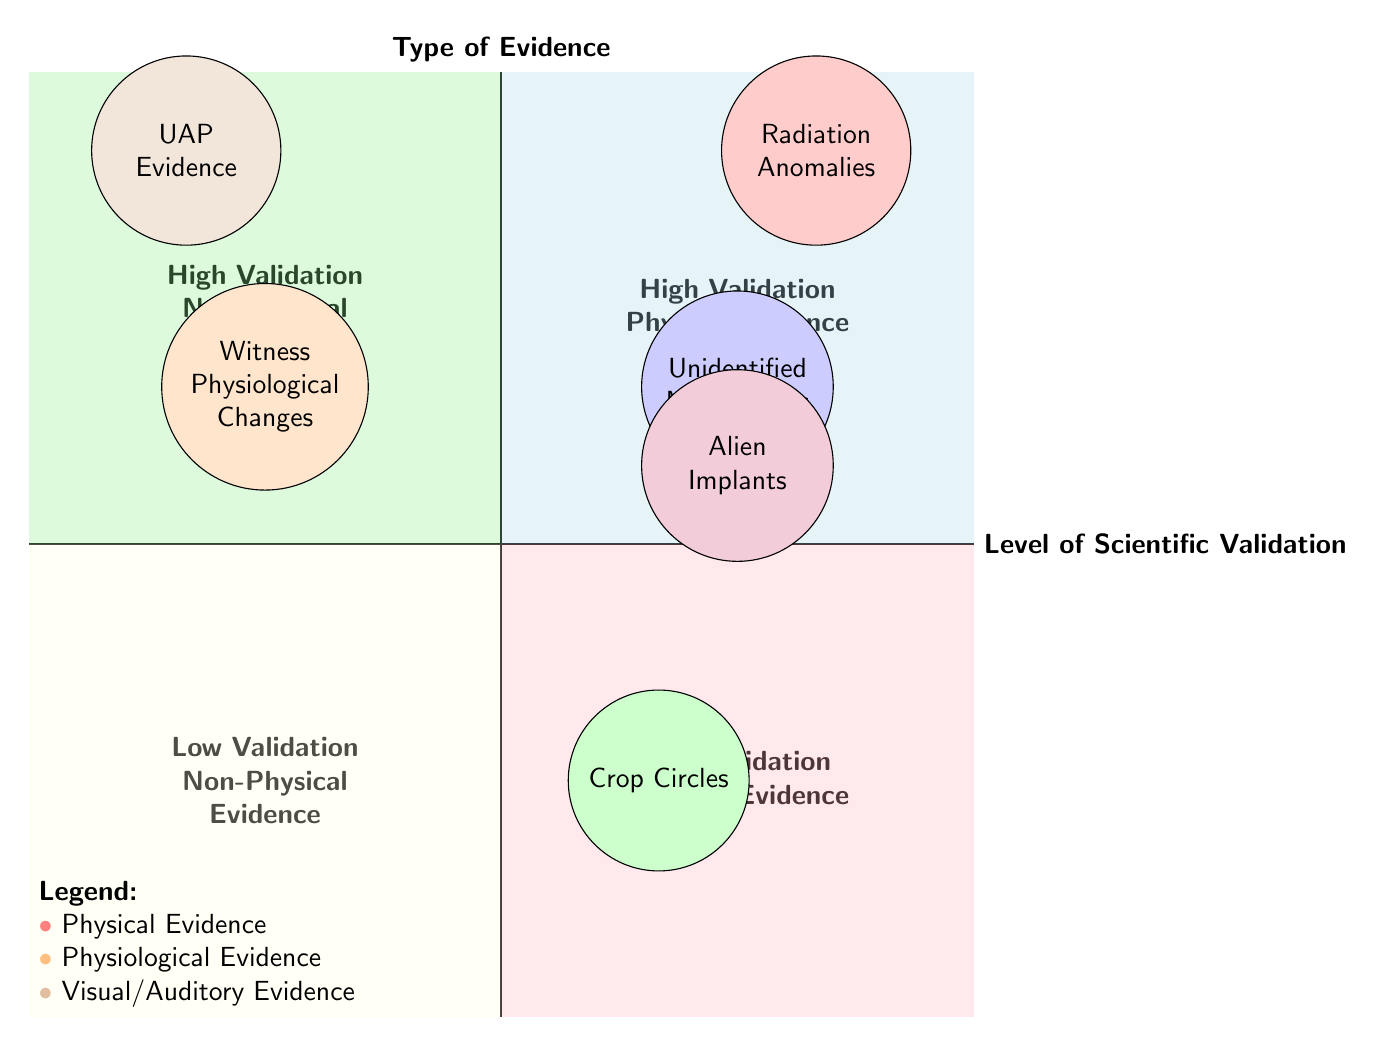What type of evidence is represented by "Radiation Anomalies"? The node "Radiation Anomalies" is located in the high validation physical evidence quadrant, indicating it is a type of physical evidence.
Answer: Physical Evidence Which evidence has the highest level of scientific validation? The chart indicates that "Radiation Anomalies" and "Unidentified Aerial Phenomena (UAP) Evidence" are both positioned in the high validation area of the diagram.
Answer: Radiation Anomalies and UAP Evidence How many types of physical evidence are found in the low validation quadrant? "Crop Circles" is the only physical evidence noted in the low validation zone, showing its location in the diagram provides the answer.
Answer: 1 What is the scientific validation level of "Alien Implants"? The node "Alien Implants" is situated in the medium validation range of the physical evidence quadrant, which classifies its level of scientific validation.
Answer: Medium How does the validation of "Witness Physiological Changes" compare to "Unidentified Metal Alloys"? "Witness Physiological Changes" is in the high validation non-physical evidence quadrant, while "Unidentified Metal Alloys" is in the medium validation physical evidence quadrant, indicating that the former is higher.
Answer: Higher Which type of evidence has the lowest scientific validation? "Crop Circles" is positioned in the low validation physical evidence quadrant, making it the evidence with the lowest scientific validation in the chart.
Answer: Crop Circles How many total types of evidence are plotted in the diagram? There are six distinct evidence types displayed across various quadrants, confirmed by counting each labeled node in the diagram.
Answer: 6 What quadrant contains visual/auditory evidence? The chart shows the top right quadrant as the area labeling high validation physical evidence, which includes "Unidentified Aerial Phenomena (UAP) Evidence".
Answer: High Validation Non-Physical Evidence 